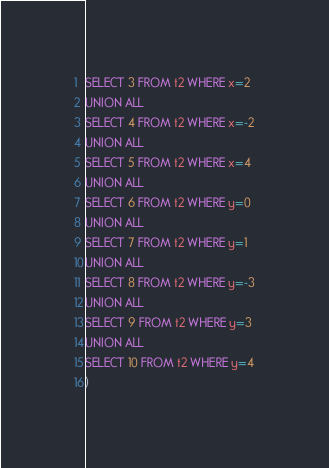<code> <loc_0><loc_0><loc_500><loc_500><_SQL_>SELECT 3 FROM t2 WHERE x=2
UNION ALL
SELECT 4 FROM t2 WHERE x=-2
UNION ALL
SELECT 5 FROM t2 WHERE x=4
UNION ALL
SELECT 6 FROM t2 WHERE y=0
UNION ALL
SELECT 7 FROM t2 WHERE y=1
UNION ALL
SELECT 8 FROM t2 WHERE y=-3
UNION ALL
SELECT 9 FROM t2 WHERE y=3
UNION ALL
SELECT 10 FROM t2 WHERE y=4
)</code> 